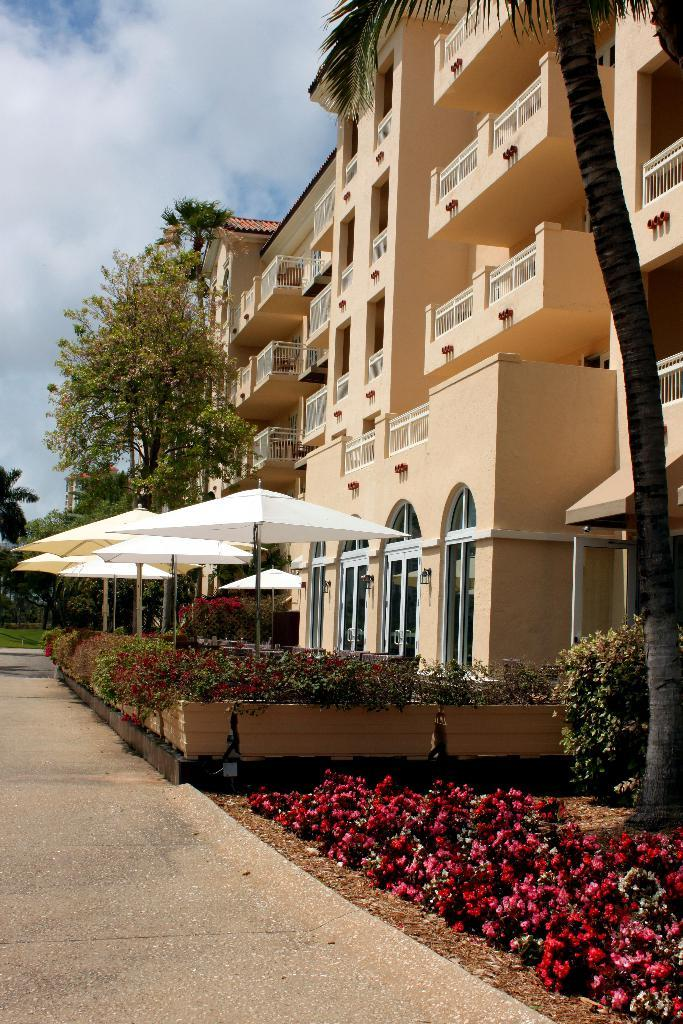What type of structures can be seen in the image? There are buildings in the image. What is located in front of the trees, plants, and flowers? There is an umbrella in front of them. What is covering the plants in the image? Canopies are above the plants. What can be seen in the background of the image? The sky is visible in the background of the image. What type of skin condition can be seen on the pig in the image? There is no pig present in the image, and therefore no skin condition can be observed. 